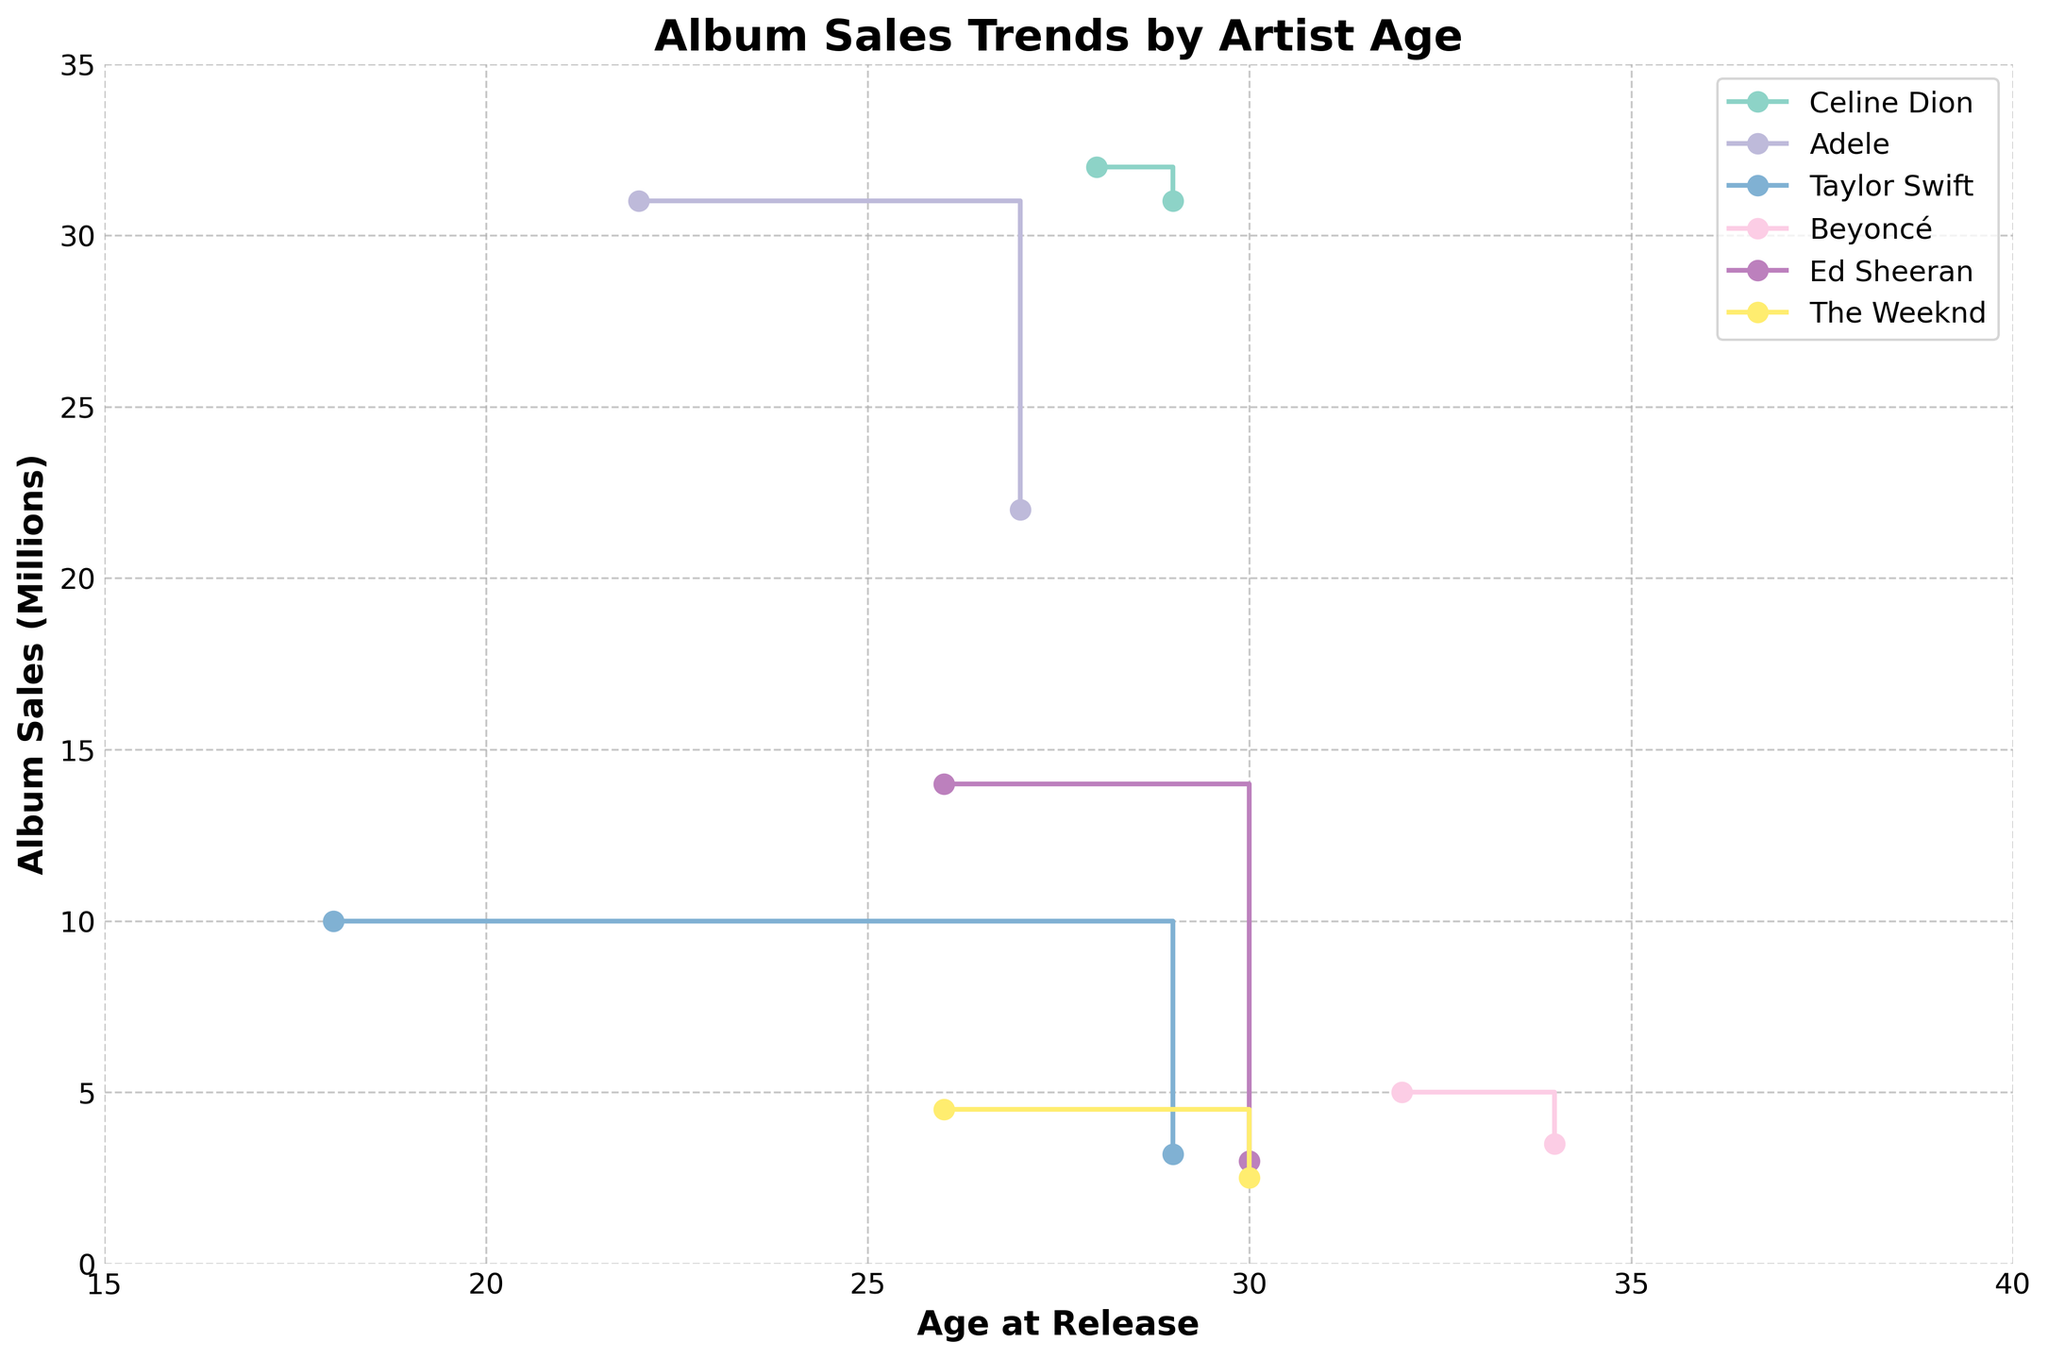What is the title of the figure? The title is displayed at the top center of the plot.
Answer: Album Sales Trends by Artist Age What is the age range covered on the x-axis? The x-axis denotes the Age at Release, and it ranges from 15 to 40.
Answer: 15 to 40 Which artist shows the steepest decline in album sales over their age range? Steep declines can be spotted where the stair step sharply drops. By examining the figure, Taylor Swift shows a steep decline from age 18 to 29.
Answer: Taylor Swift Who had the highest album sales at the youngest age depicted in the figure? The youngest age at release is 18, and the highest sales at this age are 10 million by Taylor Swift for "Fearless".
Answer: Taylor Swift Compare the album sales of Ed Sheeran at age 26 and 30. Which age had higher album sales? Locate Ed Sheeran’s data points at age 26 and 30. At age 26, album sales are 14 million, and at age 30, they are 3 million.
Answer: Age 26 Which artist had consistent album sales around 30 million during their releases? Consistent sales around 30 million can be observed by flat steps at or near 30 million. Celine Dion’s sales remain around 32 and 31 million for her albums "Falling into You" and "Let's Talk About Love".
Answer: Celine Dion Calculate the average album sales of albums released by Beyoncé. Beyoncé has two albums with sales of 5 million and 3.5 million. The average is calculated by (5 + 3.5) / 2 = 4.25 million.
Answer: 4.25 million Identify the artist who had the highest album sales at age 22. Locate the data points for age 22. Adele had sales of 31 million at this age with her album "21".
Answer: Adele How many data points on the plot are there for each artist? Each artist's number of points is shown by the number of markers with their label color. All four artists have two data points each.
Answer: 2 data points per artist 